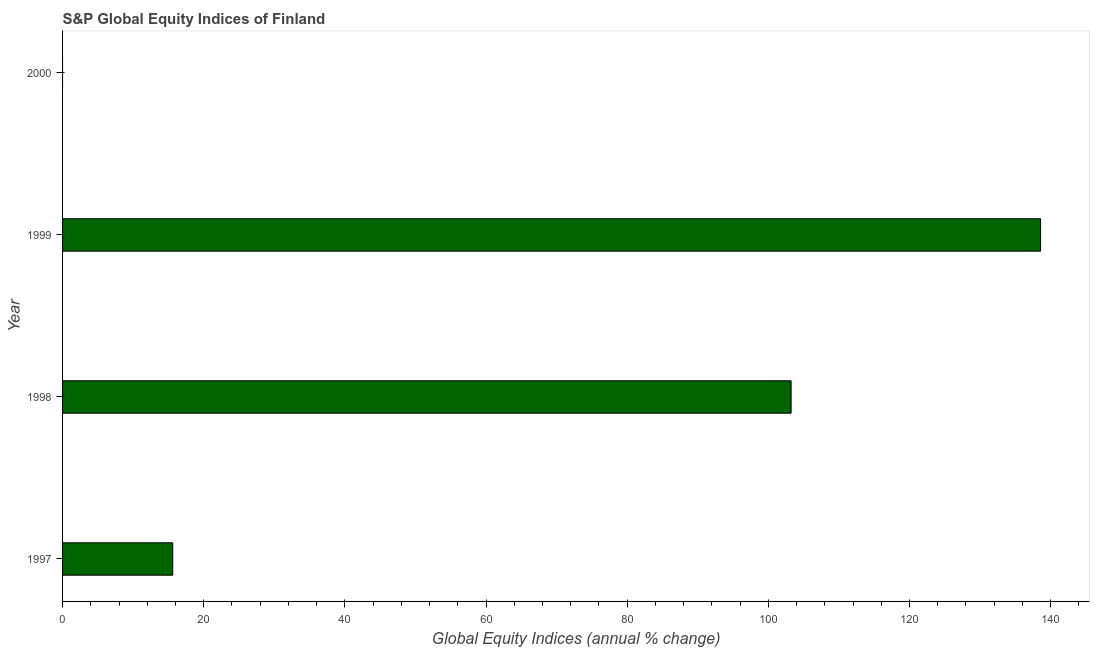What is the title of the graph?
Ensure brevity in your answer.  S&P Global Equity Indices of Finland. What is the label or title of the X-axis?
Ensure brevity in your answer.  Global Equity Indices (annual % change). What is the s&p global equity indices in 1997?
Give a very brief answer. 15.61. Across all years, what is the maximum s&p global equity indices?
Provide a short and direct response. 138.58. What is the sum of the s&p global equity indices?
Provide a succinct answer. 257.41. What is the difference between the s&p global equity indices in 1998 and 1999?
Offer a terse response. -35.35. What is the average s&p global equity indices per year?
Ensure brevity in your answer.  64.35. What is the median s&p global equity indices?
Give a very brief answer. 59.42. In how many years, is the s&p global equity indices greater than 36 %?
Provide a short and direct response. 2. What is the ratio of the s&p global equity indices in 1997 to that in 1998?
Keep it short and to the point. 0.15. Is the difference between the s&p global equity indices in 1998 and 1999 greater than the difference between any two years?
Provide a short and direct response. No. What is the difference between the highest and the second highest s&p global equity indices?
Your response must be concise. 35.35. What is the difference between the highest and the lowest s&p global equity indices?
Keep it short and to the point. 138.58. In how many years, is the s&p global equity indices greater than the average s&p global equity indices taken over all years?
Your response must be concise. 2. How many bars are there?
Provide a succinct answer. 3. Are all the bars in the graph horizontal?
Your answer should be compact. Yes. How many years are there in the graph?
Offer a very short reply. 4. What is the difference between two consecutive major ticks on the X-axis?
Make the answer very short. 20. What is the Global Equity Indices (annual % change) of 1997?
Your answer should be very brief. 15.61. What is the Global Equity Indices (annual % change) of 1998?
Offer a very short reply. 103.23. What is the Global Equity Indices (annual % change) of 1999?
Offer a very short reply. 138.58. What is the Global Equity Indices (annual % change) of 2000?
Your answer should be compact. 0. What is the difference between the Global Equity Indices (annual % change) in 1997 and 1998?
Make the answer very short. -87.61. What is the difference between the Global Equity Indices (annual % change) in 1997 and 1999?
Ensure brevity in your answer.  -122.96. What is the difference between the Global Equity Indices (annual % change) in 1998 and 1999?
Offer a very short reply. -35.35. What is the ratio of the Global Equity Indices (annual % change) in 1997 to that in 1998?
Keep it short and to the point. 0.15. What is the ratio of the Global Equity Indices (annual % change) in 1997 to that in 1999?
Provide a short and direct response. 0.11. What is the ratio of the Global Equity Indices (annual % change) in 1998 to that in 1999?
Keep it short and to the point. 0.74. 